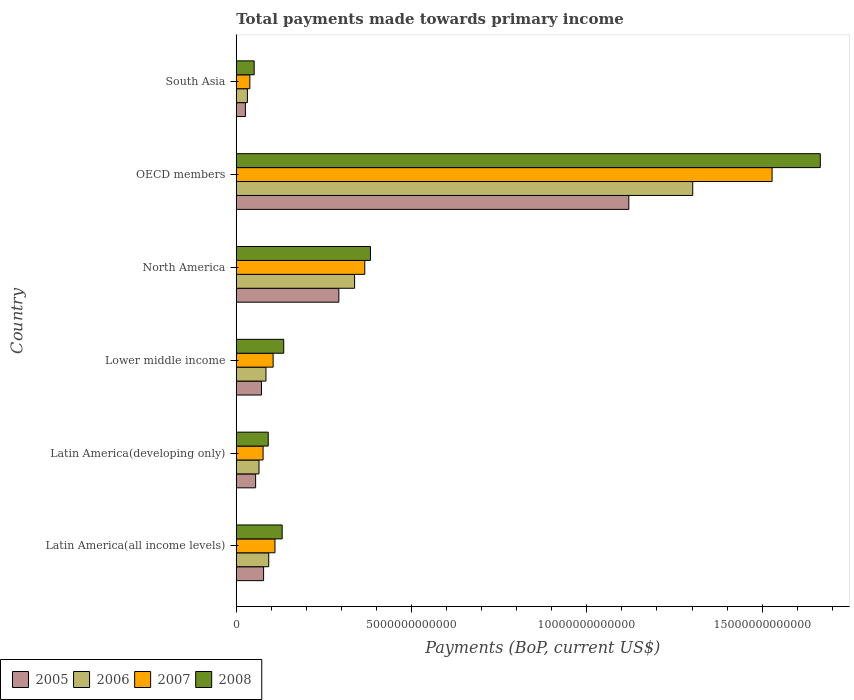How many groups of bars are there?
Provide a short and direct response. 6. Are the number of bars per tick equal to the number of legend labels?
Provide a succinct answer. Yes. Are the number of bars on each tick of the Y-axis equal?
Provide a succinct answer. Yes. What is the label of the 4th group of bars from the top?
Provide a succinct answer. Lower middle income. What is the total payments made towards primary income in 2008 in Latin America(all income levels)?
Your answer should be compact. 1.31e+12. Across all countries, what is the maximum total payments made towards primary income in 2006?
Your response must be concise. 1.30e+13. Across all countries, what is the minimum total payments made towards primary income in 2005?
Give a very brief answer. 2.61e+11. In which country was the total payments made towards primary income in 2007 maximum?
Make the answer very short. OECD members. In which country was the total payments made towards primary income in 2007 minimum?
Keep it short and to the point. South Asia. What is the total total payments made towards primary income in 2005 in the graph?
Provide a short and direct response. 1.64e+13. What is the difference between the total payments made towards primary income in 2005 in Latin America(all income levels) and that in North America?
Offer a terse response. -2.15e+12. What is the difference between the total payments made towards primary income in 2007 in Latin America(all income levels) and the total payments made towards primary income in 2008 in Lower middle income?
Keep it short and to the point. -2.50e+11. What is the average total payments made towards primary income in 2005 per country?
Keep it short and to the point. 2.74e+12. What is the difference between the total payments made towards primary income in 2008 and total payments made towards primary income in 2005 in Latin America(developing only)?
Ensure brevity in your answer.  3.60e+11. What is the ratio of the total payments made towards primary income in 2007 in Latin America(developing only) to that in OECD members?
Provide a succinct answer. 0.05. Is the difference between the total payments made towards primary income in 2008 in Lower middle income and South Asia greater than the difference between the total payments made towards primary income in 2005 in Lower middle income and South Asia?
Make the answer very short. Yes. What is the difference between the highest and the second highest total payments made towards primary income in 2008?
Your answer should be compact. 1.28e+13. What is the difference between the highest and the lowest total payments made towards primary income in 2005?
Make the answer very short. 1.09e+13. Is it the case that in every country, the sum of the total payments made towards primary income in 2006 and total payments made towards primary income in 2008 is greater than the sum of total payments made towards primary income in 2007 and total payments made towards primary income in 2005?
Your response must be concise. No. What does the 2nd bar from the bottom in Lower middle income represents?
Your answer should be very brief. 2006. Is it the case that in every country, the sum of the total payments made towards primary income in 2008 and total payments made towards primary income in 2007 is greater than the total payments made towards primary income in 2005?
Your response must be concise. Yes. How many bars are there?
Your answer should be very brief. 24. Are all the bars in the graph horizontal?
Ensure brevity in your answer.  Yes. What is the difference between two consecutive major ticks on the X-axis?
Your answer should be compact. 5.00e+12. Are the values on the major ticks of X-axis written in scientific E-notation?
Offer a terse response. No. Does the graph contain any zero values?
Give a very brief answer. No. How many legend labels are there?
Give a very brief answer. 4. How are the legend labels stacked?
Your answer should be very brief. Horizontal. What is the title of the graph?
Your response must be concise. Total payments made towards primary income. Does "1995" appear as one of the legend labels in the graph?
Make the answer very short. No. What is the label or title of the X-axis?
Ensure brevity in your answer.  Payments (BoP, current US$). What is the Payments (BoP, current US$) of 2005 in Latin America(all income levels)?
Provide a succinct answer. 7.80e+11. What is the Payments (BoP, current US$) of 2006 in Latin America(all income levels)?
Your answer should be very brief. 9.27e+11. What is the Payments (BoP, current US$) of 2007 in Latin America(all income levels)?
Provide a succinct answer. 1.10e+12. What is the Payments (BoP, current US$) of 2008 in Latin America(all income levels)?
Keep it short and to the point. 1.31e+12. What is the Payments (BoP, current US$) in 2005 in Latin America(developing only)?
Keep it short and to the point. 5.52e+11. What is the Payments (BoP, current US$) of 2006 in Latin America(developing only)?
Your answer should be compact. 6.49e+11. What is the Payments (BoP, current US$) in 2007 in Latin America(developing only)?
Your response must be concise. 7.65e+11. What is the Payments (BoP, current US$) of 2008 in Latin America(developing only)?
Give a very brief answer. 9.12e+11. What is the Payments (BoP, current US$) of 2005 in Lower middle income?
Your answer should be compact. 7.19e+11. What is the Payments (BoP, current US$) in 2006 in Lower middle income?
Your response must be concise. 8.48e+11. What is the Payments (BoP, current US$) of 2007 in Lower middle income?
Give a very brief answer. 1.05e+12. What is the Payments (BoP, current US$) in 2008 in Lower middle income?
Your response must be concise. 1.35e+12. What is the Payments (BoP, current US$) of 2005 in North America?
Offer a very short reply. 2.93e+12. What is the Payments (BoP, current US$) of 2006 in North America?
Give a very brief answer. 3.38e+12. What is the Payments (BoP, current US$) in 2007 in North America?
Your answer should be very brief. 3.67e+12. What is the Payments (BoP, current US$) of 2008 in North America?
Give a very brief answer. 3.83e+12. What is the Payments (BoP, current US$) of 2005 in OECD members?
Keep it short and to the point. 1.12e+13. What is the Payments (BoP, current US$) in 2006 in OECD members?
Your answer should be compact. 1.30e+13. What is the Payments (BoP, current US$) of 2007 in OECD members?
Provide a short and direct response. 1.53e+13. What is the Payments (BoP, current US$) of 2008 in OECD members?
Make the answer very short. 1.67e+13. What is the Payments (BoP, current US$) of 2005 in South Asia?
Provide a succinct answer. 2.61e+11. What is the Payments (BoP, current US$) in 2006 in South Asia?
Give a very brief answer. 3.18e+11. What is the Payments (BoP, current US$) in 2007 in South Asia?
Your answer should be very brief. 3.88e+11. What is the Payments (BoP, current US$) in 2008 in South Asia?
Offer a very short reply. 5.11e+11. Across all countries, what is the maximum Payments (BoP, current US$) of 2005?
Your answer should be very brief. 1.12e+13. Across all countries, what is the maximum Payments (BoP, current US$) of 2006?
Offer a terse response. 1.30e+13. Across all countries, what is the maximum Payments (BoP, current US$) of 2007?
Ensure brevity in your answer.  1.53e+13. Across all countries, what is the maximum Payments (BoP, current US$) in 2008?
Make the answer very short. 1.67e+13. Across all countries, what is the minimum Payments (BoP, current US$) of 2005?
Your response must be concise. 2.61e+11. Across all countries, what is the minimum Payments (BoP, current US$) of 2006?
Your response must be concise. 3.18e+11. Across all countries, what is the minimum Payments (BoP, current US$) of 2007?
Your response must be concise. 3.88e+11. Across all countries, what is the minimum Payments (BoP, current US$) in 2008?
Offer a very short reply. 5.11e+11. What is the total Payments (BoP, current US$) of 2005 in the graph?
Your answer should be compact. 1.64e+13. What is the total Payments (BoP, current US$) of 2006 in the graph?
Provide a succinct answer. 1.91e+13. What is the total Payments (BoP, current US$) in 2007 in the graph?
Keep it short and to the point. 2.23e+13. What is the total Payments (BoP, current US$) of 2008 in the graph?
Provide a short and direct response. 2.46e+13. What is the difference between the Payments (BoP, current US$) in 2005 in Latin America(all income levels) and that in Latin America(developing only)?
Offer a very short reply. 2.27e+11. What is the difference between the Payments (BoP, current US$) in 2006 in Latin America(all income levels) and that in Latin America(developing only)?
Your answer should be compact. 2.78e+11. What is the difference between the Payments (BoP, current US$) in 2007 in Latin America(all income levels) and that in Latin America(developing only)?
Your answer should be very brief. 3.39e+11. What is the difference between the Payments (BoP, current US$) of 2008 in Latin America(all income levels) and that in Latin America(developing only)?
Offer a very short reply. 3.97e+11. What is the difference between the Payments (BoP, current US$) of 2005 in Latin America(all income levels) and that in Lower middle income?
Provide a short and direct response. 6.05e+1. What is the difference between the Payments (BoP, current US$) of 2006 in Latin America(all income levels) and that in Lower middle income?
Provide a short and direct response. 7.89e+1. What is the difference between the Payments (BoP, current US$) of 2007 in Latin America(all income levels) and that in Lower middle income?
Ensure brevity in your answer.  5.23e+1. What is the difference between the Payments (BoP, current US$) of 2008 in Latin America(all income levels) and that in Lower middle income?
Your response must be concise. -4.54e+1. What is the difference between the Payments (BoP, current US$) in 2005 in Latin America(all income levels) and that in North America?
Give a very brief answer. -2.15e+12. What is the difference between the Payments (BoP, current US$) in 2006 in Latin America(all income levels) and that in North America?
Make the answer very short. -2.45e+12. What is the difference between the Payments (BoP, current US$) of 2007 in Latin America(all income levels) and that in North America?
Provide a short and direct response. -2.56e+12. What is the difference between the Payments (BoP, current US$) in 2008 in Latin America(all income levels) and that in North America?
Provide a succinct answer. -2.52e+12. What is the difference between the Payments (BoP, current US$) of 2005 in Latin America(all income levels) and that in OECD members?
Provide a short and direct response. -1.04e+13. What is the difference between the Payments (BoP, current US$) in 2006 in Latin America(all income levels) and that in OECD members?
Offer a very short reply. -1.21e+13. What is the difference between the Payments (BoP, current US$) of 2007 in Latin America(all income levels) and that in OECD members?
Offer a terse response. -1.42e+13. What is the difference between the Payments (BoP, current US$) of 2008 in Latin America(all income levels) and that in OECD members?
Offer a terse response. -1.54e+13. What is the difference between the Payments (BoP, current US$) in 2005 in Latin America(all income levels) and that in South Asia?
Your answer should be very brief. 5.19e+11. What is the difference between the Payments (BoP, current US$) in 2006 in Latin America(all income levels) and that in South Asia?
Offer a very short reply. 6.09e+11. What is the difference between the Payments (BoP, current US$) of 2007 in Latin America(all income levels) and that in South Asia?
Ensure brevity in your answer.  7.17e+11. What is the difference between the Payments (BoP, current US$) of 2008 in Latin America(all income levels) and that in South Asia?
Your answer should be very brief. 7.98e+11. What is the difference between the Payments (BoP, current US$) in 2005 in Latin America(developing only) and that in Lower middle income?
Offer a terse response. -1.67e+11. What is the difference between the Payments (BoP, current US$) of 2006 in Latin America(developing only) and that in Lower middle income?
Keep it short and to the point. -1.99e+11. What is the difference between the Payments (BoP, current US$) of 2007 in Latin America(developing only) and that in Lower middle income?
Your answer should be compact. -2.86e+11. What is the difference between the Payments (BoP, current US$) of 2008 in Latin America(developing only) and that in Lower middle income?
Your response must be concise. -4.42e+11. What is the difference between the Payments (BoP, current US$) of 2005 in Latin America(developing only) and that in North America?
Give a very brief answer. -2.37e+12. What is the difference between the Payments (BoP, current US$) in 2006 in Latin America(developing only) and that in North America?
Provide a succinct answer. -2.73e+12. What is the difference between the Payments (BoP, current US$) in 2007 in Latin America(developing only) and that in North America?
Give a very brief answer. -2.90e+12. What is the difference between the Payments (BoP, current US$) of 2008 in Latin America(developing only) and that in North America?
Keep it short and to the point. -2.92e+12. What is the difference between the Payments (BoP, current US$) of 2005 in Latin America(developing only) and that in OECD members?
Give a very brief answer. -1.06e+13. What is the difference between the Payments (BoP, current US$) of 2006 in Latin America(developing only) and that in OECD members?
Ensure brevity in your answer.  -1.24e+13. What is the difference between the Payments (BoP, current US$) of 2007 in Latin America(developing only) and that in OECD members?
Your response must be concise. -1.45e+13. What is the difference between the Payments (BoP, current US$) of 2008 in Latin America(developing only) and that in OECD members?
Your answer should be very brief. -1.57e+13. What is the difference between the Payments (BoP, current US$) in 2005 in Latin America(developing only) and that in South Asia?
Provide a short and direct response. 2.92e+11. What is the difference between the Payments (BoP, current US$) of 2006 in Latin America(developing only) and that in South Asia?
Provide a short and direct response. 3.31e+11. What is the difference between the Payments (BoP, current US$) of 2007 in Latin America(developing only) and that in South Asia?
Provide a succinct answer. 3.78e+11. What is the difference between the Payments (BoP, current US$) of 2008 in Latin America(developing only) and that in South Asia?
Your response must be concise. 4.01e+11. What is the difference between the Payments (BoP, current US$) of 2005 in Lower middle income and that in North America?
Your answer should be compact. -2.21e+12. What is the difference between the Payments (BoP, current US$) of 2006 in Lower middle income and that in North America?
Ensure brevity in your answer.  -2.53e+12. What is the difference between the Payments (BoP, current US$) of 2007 in Lower middle income and that in North America?
Your answer should be compact. -2.61e+12. What is the difference between the Payments (BoP, current US$) in 2008 in Lower middle income and that in North America?
Your answer should be very brief. -2.47e+12. What is the difference between the Payments (BoP, current US$) in 2005 in Lower middle income and that in OECD members?
Offer a very short reply. -1.05e+13. What is the difference between the Payments (BoP, current US$) in 2006 in Lower middle income and that in OECD members?
Offer a very short reply. -1.22e+13. What is the difference between the Payments (BoP, current US$) in 2007 in Lower middle income and that in OECD members?
Provide a short and direct response. -1.42e+13. What is the difference between the Payments (BoP, current US$) in 2008 in Lower middle income and that in OECD members?
Offer a terse response. -1.53e+13. What is the difference between the Payments (BoP, current US$) of 2005 in Lower middle income and that in South Asia?
Provide a short and direct response. 4.59e+11. What is the difference between the Payments (BoP, current US$) of 2006 in Lower middle income and that in South Asia?
Your response must be concise. 5.30e+11. What is the difference between the Payments (BoP, current US$) of 2007 in Lower middle income and that in South Asia?
Offer a terse response. 6.64e+11. What is the difference between the Payments (BoP, current US$) in 2008 in Lower middle income and that in South Asia?
Provide a succinct answer. 8.43e+11. What is the difference between the Payments (BoP, current US$) in 2005 in North America and that in OECD members?
Offer a terse response. -8.27e+12. What is the difference between the Payments (BoP, current US$) of 2006 in North America and that in OECD members?
Offer a terse response. -9.65e+12. What is the difference between the Payments (BoP, current US$) of 2007 in North America and that in OECD members?
Your answer should be very brief. -1.16e+13. What is the difference between the Payments (BoP, current US$) of 2008 in North America and that in OECD members?
Give a very brief answer. -1.28e+13. What is the difference between the Payments (BoP, current US$) of 2005 in North America and that in South Asia?
Keep it short and to the point. 2.67e+12. What is the difference between the Payments (BoP, current US$) in 2006 in North America and that in South Asia?
Provide a short and direct response. 3.06e+12. What is the difference between the Payments (BoP, current US$) of 2007 in North America and that in South Asia?
Your response must be concise. 3.28e+12. What is the difference between the Payments (BoP, current US$) of 2008 in North America and that in South Asia?
Give a very brief answer. 3.32e+12. What is the difference between the Payments (BoP, current US$) of 2005 in OECD members and that in South Asia?
Your response must be concise. 1.09e+13. What is the difference between the Payments (BoP, current US$) in 2006 in OECD members and that in South Asia?
Provide a succinct answer. 1.27e+13. What is the difference between the Payments (BoP, current US$) in 2007 in OECD members and that in South Asia?
Make the answer very short. 1.49e+13. What is the difference between the Payments (BoP, current US$) of 2008 in OECD members and that in South Asia?
Ensure brevity in your answer.  1.61e+13. What is the difference between the Payments (BoP, current US$) of 2005 in Latin America(all income levels) and the Payments (BoP, current US$) of 2006 in Latin America(developing only)?
Your answer should be very brief. 1.31e+11. What is the difference between the Payments (BoP, current US$) in 2005 in Latin America(all income levels) and the Payments (BoP, current US$) in 2007 in Latin America(developing only)?
Provide a short and direct response. 1.43e+1. What is the difference between the Payments (BoP, current US$) in 2005 in Latin America(all income levels) and the Payments (BoP, current US$) in 2008 in Latin America(developing only)?
Offer a terse response. -1.33e+11. What is the difference between the Payments (BoP, current US$) of 2006 in Latin America(all income levels) and the Payments (BoP, current US$) of 2007 in Latin America(developing only)?
Provide a short and direct response. 1.61e+11. What is the difference between the Payments (BoP, current US$) of 2006 in Latin America(all income levels) and the Payments (BoP, current US$) of 2008 in Latin America(developing only)?
Provide a short and direct response. 1.44e+1. What is the difference between the Payments (BoP, current US$) in 2007 in Latin America(all income levels) and the Payments (BoP, current US$) in 2008 in Latin America(developing only)?
Offer a very short reply. 1.92e+11. What is the difference between the Payments (BoP, current US$) of 2005 in Latin America(all income levels) and the Payments (BoP, current US$) of 2006 in Lower middle income?
Offer a very short reply. -6.81e+1. What is the difference between the Payments (BoP, current US$) in 2005 in Latin America(all income levels) and the Payments (BoP, current US$) in 2007 in Lower middle income?
Ensure brevity in your answer.  -2.72e+11. What is the difference between the Payments (BoP, current US$) of 2005 in Latin America(all income levels) and the Payments (BoP, current US$) of 2008 in Lower middle income?
Make the answer very short. -5.75e+11. What is the difference between the Payments (BoP, current US$) in 2006 in Latin America(all income levels) and the Payments (BoP, current US$) in 2007 in Lower middle income?
Give a very brief answer. -1.25e+11. What is the difference between the Payments (BoP, current US$) in 2006 in Latin America(all income levels) and the Payments (BoP, current US$) in 2008 in Lower middle income?
Offer a very short reply. -4.28e+11. What is the difference between the Payments (BoP, current US$) in 2007 in Latin America(all income levels) and the Payments (BoP, current US$) in 2008 in Lower middle income?
Your response must be concise. -2.50e+11. What is the difference between the Payments (BoP, current US$) in 2005 in Latin America(all income levels) and the Payments (BoP, current US$) in 2006 in North America?
Provide a short and direct response. -2.60e+12. What is the difference between the Payments (BoP, current US$) in 2005 in Latin America(all income levels) and the Payments (BoP, current US$) in 2007 in North America?
Offer a terse response. -2.89e+12. What is the difference between the Payments (BoP, current US$) of 2005 in Latin America(all income levels) and the Payments (BoP, current US$) of 2008 in North America?
Your response must be concise. -3.05e+12. What is the difference between the Payments (BoP, current US$) in 2006 in Latin America(all income levels) and the Payments (BoP, current US$) in 2007 in North America?
Give a very brief answer. -2.74e+12. What is the difference between the Payments (BoP, current US$) of 2006 in Latin America(all income levels) and the Payments (BoP, current US$) of 2008 in North America?
Keep it short and to the point. -2.90e+12. What is the difference between the Payments (BoP, current US$) in 2007 in Latin America(all income levels) and the Payments (BoP, current US$) in 2008 in North America?
Keep it short and to the point. -2.72e+12. What is the difference between the Payments (BoP, current US$) of 2005 in Latin America(all income levels) and the Payments (BoP, current US$) of 2006 in OECD members?
Offer a terse response. -1.22e+13. What is the difference between the Payments (BoP, current US$) of 2005 in Latin America(all income levels) and the Payments (BoP, current US$) of 2007 in OECD members?
Make the answer very short. -1.45e+13. What is the difference between the Payments (BoP, current US$) of 2005 in Latin America(all income levels) and the Payments (BoP, current US$) of 2008 in OECD members?
Give a very brief answer. -1.59e+13. What is the difference between the Payments (BoP, current US$) in 2006 in Latin America(all income levels) and the Payments (BoP, current US$) in 2007 in OECD members?
Your response must be concise. -1.44e+13. What is the difference between the Payments (BoP, current US$) in 2006 in Latin America(all income levels) and the Payments (BoP, current US$) in 2008 in OECD members?
Provide a short and direct response. -1.57e+13. What is the difference between the Payments (BoP, current US$) of 2007 in Latin America(all income levels) and the Payments (BoP, current US$) of 2008 in OECD members?
Your answer should be very brief. -1.56e+13. What is the difference between the Payments (BoP, current US$) in 2005 in Latin America(all income levels) and the Payments (BoP, current US$) in 2006 in South Asia?
Ensure brevity in your answer.  4.62e+11. What is the difference between the Payments (BoP, current US$) in 2005 in Latin America(all income levels) and the Payments (BoP, current US$) in 2007 in South Asia?
Make the answer very short. 3.92e+11. What is the difference between the Payments (BoP, current US$) in 2005 in Latin America(all income levels) and the Payments (BoP, current US$) in 2008 in South Asia?
Your answer should be compact. 2.68e+11. What is the difference between the Payments (BoP, current US$) in 2006 in Latin America(all income levels) and the Payments (BoP, current US$) in 2007 in South Asia?
Make the answer very short. 5.39e+11. What is the difference between the Payments (BoP, current US$) of 2006 in Latin America(all income levels) and the Payments (BoP, current US$) of 2008 in South Asia?
Offer a terse response. 4.15e+11. What is the difference between the Payments (BoP, current US$) of 2007 in Latin America(all income levels) and the Payments (BoP, current US$) of 2008 in South Asia?
Ensure brevity in your answer.  5.93e+11. What is the difference between the Payments (BoP, current US$) in 2005 in Latin America(developing only) and the Payments (BoP, current US$) in 2006 in Lower middle income?
Your response must be concise. -2.95e+11. What is the difference between the Payments (BoP, current US$) in 2005 in Latin America(developing only) and the Payments (BoP, current US$) in 2007 in Lower middle income?
Make the answer very short. -4.99e+11. What is the difference between the Payments (BoP, current US$) of 2005 in Latin America(developing only) and the Payments (BoP, current US$) of 2008 in Lower middle income?
Your answer should be very brief. -8.02e+11. What is the difference between the Payments (BoP, current US$) in 2006 in Latin America(developing only) and the Payments (BoP, current US$) in 2007 in Lower middle income?
Your response must be concise. -4.03e+11. What is the difference between the Payments (BoP, current US$) in 2006 in Latin America(developing only) and the Payments (BoP, current US$) in 2008 in Lower middle income?
Keep it short and to the point. -7.05e+11. What is the difference between the Payments (BoP, current US$) in 2007 in Latin America(developing only) and the Payments (BoP, current US$) in 2008 in Lower middle income?
Offer a terse response. -5.89e+11. What is the difference between the Payments (BoP, current US$) in 2005 in Latin America(developing only) and the Payments (BoP, current US$) in 2006 in North America?
Ensure brevity in your answer.  -2.82e+12. What is the difference between the Payments (BoP, current US$) of 2005 in Latin America(developing only) and the Payments (BoP, current US$) of 2007 in North America?
Your response must be concise. -3.11e+12. What is the difference between the Payments (BoP, current US$) in 2005 in Latin America(developing only) and the Payments (BoP, current US$) in 2008 in North America?
Make the answer very short. -3.28e+12. What is the difference between the Payments (BoP, current US$) in 2006 in Latin America(developing only) and the Payments (BoP, current US$) in 2007 in North America?
Your answer should be compact. -3.02e+12. What is the difference between the Payments (BoP, current US$) in 2006 in Latin America(developing only) and the Payments (BoP, current US$) in 2008 in North America?
Give a very brief answer. -3.18e+12. What is the difference between the Payments (BoP, current US$) in 2007 in Latin America(developing only) and the Payments (BoP, current US$) in 2008 in North America?
Provide a short and direct response. -3.06e+12. What is the difference between the Payments (BoP, current US$) in 2005 in Latin America(developing only) and the Payments (BoP, current US$) in 2006 in OECD members?
Ensure brevity in your answer.  -1.25e+13. What is the difference between the Payments (BoP, current US$) of 2005 in Latin America(developing only) and the Payments (BoP, current US$) of 2007 in OECD members?
Provide a short and direct response. -1.47e+13. What is the difference between the Payments (BoP, current US$) in 2005 in Latin America(developing only) and the Payments (BoP, current US$) in 2008 in OECD members?
Your response must be concise. -1.61e+13. What is the difference between the Payments (BoP, current US$) of 2006 in Latin America(developing only) and the Payments (BoP, current US$) of 2007 in OECD members?
Provide a short and direct response. -1.46e+13. What is the difference between the Payments (BoP, current US$) of 2006 in Latin America(developing only) and the Payments (BoP, current US$) of 2008 in OECD members?
Your answer should be compact. -1.60e+13. What is the difference between the Payments (BoP, current US$) in 2007 in Latin America(developing only) and the Payments (BoP, current US$) in 2008 in OECD members?
Offer a very short reply. -1.59e+13. What is the difference between the Payments (BoP, current US$) of 2005 in Latin America(developing only) and the Payments (BoP, current US$) of 2006 in South Asia?
Your response must be concise. 2.34e+11. What is the difference between the Payments (BoP, current US$) of 2005 in Latin America(developing only) and the Payments (BoP, current US$) of 2007 in South Asia?
Your response must be concise. 1.65e+11. What is the difference between the Payments (BoP, current US$) of 2005 in Latin America(developing only) and the Payments (BoP, current US$) of 2008 in South Asia?
Your answer should be very brief. 4.13e+1. What is the difference between the Payments (BoP, current US$) of 2006 in Latin America(developing only) and the Payments (BoP, current US$) of 2007 in South Asia?
Give a very brief answer. 2.61e+11. What is the difference between the Payments (BoP, current US$) of 2006 in Latin America(developing only) and the Payments (BoP, current US$) of 2008 in South Asia?
Offer a terse response. 1.38e+11. What is the difference between the Payments (BoP, current US$) in 2007 in Latin America(developing only) and the Payments (BoP, current US$) in 2008 in South Asia?
Offer a very short reply. 2.54e+11. What is the difference between the Payments (BoP, current US$) in 2005 in Lower middle income and the Payments (BoP, current US$) in 2006 in North America?
Your response must be concise. -2.66e+12. What is the difference between the Payments (BoP, current US$) in 2005 in Lower middle income and the Payments (BoP, current US$) in 2007 in North America?
Offer a very short reply. -2.95e+12. What is the difference between the Payments (BoP, current US$) of 2005 in Lower middle income and the Payments (BoP, current US$) of 2008 in North America?
Keep it short and to the point. -3.11e+12. What is the difference between the Payments (BoP, current US$) in 2006 in Lower middle income and the Payments (BoP, current US$) in 2007 in North America?
Your answer should be very brief. -2.82e+12. What is the difference between the Payments (BoP, current US$) of 2006 in Lower middle income and the Payments (BoP, current US$) of 2008 in North America?
Your answer should be compact. -2.98e+12. What is the difference between the Payments (BoP, current US$) of 2007 in Lower middle income and the Payments (BoP, current US$) of 2008 in North America?
Ensure brevity in your answer.  -2.78e+12. What is the difference between the Payments (BoP, current US$) of 2005 in Lower middle income and the Payments (BoP, current US$) of 2006 in OECD members?
Ensure brevity in your answer.  -1.23e+13. What is the difference between the Payments (BoP, current US$) of 2005 in Lower middle income and the Payments (BoP, current US$) of 2007 in OECD members?
Provide a succinct answer. -1.46e+13. What is the difference between the Payments (BoP, current US$) in 2005 in Lower middle income and the Payments (BoP, current US$) in 2008 in OECD members?
Give a very brief answer. -1.59e+13. What is the difference between the Payments (BoP, current US$) in 2006 in Lower middle income and the Payments (BoP, current US$) in 2007 in OECD members?
Keep it short and to the point. -1.44e+13. What is the difference between the Payments (BoP, current US$) in 2006 in Lower middle income and the Payments (BoP, current US$) in 2008 in OECD members?
Your answer should be compact. -1.58e+13. What is the difference between the Payments (BoP, current US$) of 2007 in Lower middle income and the Payments (BoP, current US$) of 2008 in OECD members?
Provide a short and direct response. -1.56e+13. What is the difference between the Payments (BoP, current US$) of 2005 in Lower middle income and the Payments (BoP, current US$) of 2006 in South Asia?
Your answer should be very brief. 4.01e+11. What is the difference between the Payments (BoP, current US$) in 2005 in Lower middle income and the Payments (BoP, current US$) in 2007 in South Asia?
Offer a terse response. 3.32e+11. What is the difference between the Payments (BoP, current US$) of 2005 in Lower middle income and the Payments (BoP, current US$) of 2008 in South Asia?
Ensure brevity in your answer.  2.08e+11. What is the difference between the Payments (BoP, current US$) in 2006 in Lower middle income and the Payments (BoP, current US$) in 2007 in South Asia?
Your answer should be very brief. 4.60e+11. What is the difference between the Payments (BoP, current US$) of 2006 in Lower middle income and the Payments (BoP, current US$) of 2008 in South Asia?
Keep it short and to the point. 3.37e+11. What is the difference between the Payments (BoP, current US$) in 2007 in Lower middle income and the Payments (BoP, current US$) in 2008 in South Asia?
Keep it short and to the point. 5.41e+11. What is the difference between the Payments (BoP, current US$) in 2005 in North America and the Payments (BoP, current US$) in 2006 in OECD members?
Make the answer very short. -1.01e+13. What is the difference between the Payments (BoP, current US$) of 2005 in North America and the Payments (BoP, current US$) of 2007 in OECD members?
Make the answer very short. -1.24e+13. What is the difference between the Payments (BoP, current US$) in 2005 in North America and the Payments (BoP, current US$) in 2008 in OECD members?
Your answer should be compact. -1.37e+13. What is the difference between the Payments (BoP, current US$) of 2006 in North America and the Payments (BoP, current US$) of 2007 in OECD members?
Make the answer very short. -1.19e+13. What is the difference between the Payments (BoP, current US$) in 2006 in North America and the Payments (BoP, current US$) in 2008 in OECD members?
Provide a succinct answer. -1.33e+13. What is the difference between the Payments (BoP, current US$) of 2007 in North America and the Payments (BoP, current US$) of 2008 in OECD members?
Give a very brief answer. -1.30e+13. What is the difference between the Payments (BoP, current US$) of 2005 in North America and the Payments (BoP, current US$) of 2006 in South Asia?
Give a very brief answer. 2.61e+12. What is the difference between the Payments (BoP, current US$) in 2005 in North America and the Payments (BoP, current US$) in 2007 in South Asia?
Provide a short and direct response. 2.54e+12. What is the difference between the Payments (BoP, current US$) of 2005 in North America and the Payments (BoP, current US$) of 2008 in South Asia?
Provide a succinct answer. 2.41e+12. What is the difference between the Payments (BoP, current US$) in 2006 in North America and the Payments (BoP, current US$) in 2007 in South Asia?
Keep it short and to the point. 2.99e+12. What is the difference between the Payments (BoP, current US$) in 2006 in North America and the Payments (BoP, current US$) in 2008 in South Asia?
Give a very brief answer. 2.86e+12. What is the difference between the Payments (BoP, current US$) of 2007 in North America and the Payments (BoP, current US$) of 2008 in South Asia?
Provide a succinct answer. 3.15e+12. What is the difference between the Payments (BoP, current US$) of 2005 in OECD members and the Payments (BoP, current US$) of 2006 in South Asia?
Provide a short and direct response. 1.09e+13. What is the difference between the Payments (BoP, current US$) of 2005 in OECD members and the Payments (BoP, current US$) of 2007 in South Asia?
Offer a terse response. 1.08e+13. What is the difference between the Payments (BoP, current US$) in 2005 in OECD members and the Payments (BoP, current US$) in 2008 in South Asia?
Your response must be concise. 1.07e+13. What is the difference between the Payments (BoP, current US$) in 2006 in OECD members and the Payments (BoP, current US$) in 2007 in South Asia?
Your response must be concise. 1.26e+13. What is the difference between the Payments (BoP, current US$) of 2006 in OECD members and the Payments (BoP, current US$) of 2008 in South Asia?
Ensure brevity in your answer.  1.25e+13. What is the difference between the Payments (BoP, current US$) in 2007 in OECD members and the Payments (BoP, current US$) in 2008 in South Asia?
Your response must be concise. 1.48e+13. What is the average Payments (BoP, current US$) in 2005 per country?
Provide a succinct answer. 2.74e+12. What is the average Payments (BoP, current US$) of 2006 per country?
Give a very brief answer. 3.19e+12. What is the average Payments (BoP, current US$) in 2007 per country?
Your answer should be very brief. 3.71e+12. What is the average Payments (BoP, current US$) in 2008 per country?
Your answer should be compact. 4.10e+12. What is the difference between the Payments (BoP, current US$) in 2005 and Payments (BoP, current US$) in 2006 in Latin America(all income levels)?
Your answer should be very brief. -1.47e+11. What is the difference between the Payments (BoP, current US$) of 2005 and Payments (BoP, current US$) of 2007 in Latin America(all income levels)?
Provide a short and direct response. -3.25e+11. What is the difference between the Payments (BoP, current US$) in 2005 and Payments (BoP, current US$) in 2008 in Latin America(all income levels)?
Your answer should be compact. -5.29e+11. What is the difference between the Payments (BoP, current US$) in 2006 and Payments (BoP, current US$) in 2007 in Latin America(all income levels)?
Offer a terse response. -1.78e+11. What is the difference between the Payments (BoP, current US$) of 2006 and Payments (BoP, current US$) of 2008 in Latin America(all income levels)?
Your answer should be very brief. -3.82e+11. What is the difference between the Payments (BoP, current US$) of 2007 and Payments (BoP, current US$) of 2008 in Latin America(all income levels)?
Provide a short and direct response. -2.05e+11. What is the difference between the Payments (BoP, current US$) of 2005 and Payments (BoP, current US$) of 2006 in Latin America(developing only)?
Offer a very short reply. -9.65e+1. What is the difference between the Payments (BoP, current US$) in 2005 and Payments (BoP, current US$) in 2007 in Latin America(developing only)?
Ensure brevity in your answer.  -2.13e+11. What is the difference between the Payments (BoP, current US$) of 2005 and Payments (BoP, current US$) of 2008 in Latin America(developing only)?
Your response must be concise. -3.60e+11. What is the difference between the Payments (BoP, current US$) in 2006 and Payments (BoP, current US$) in 2007 in Latin America(developing only)?
Provide a short and direct response. -1.16e+11. What is the difference between the Payments (BoP, current US$) of 2006 and Payments (BoP, current US$) of 2008 in Latin America(developing only)?
Offer a terse response. -2.63e+11. What is the difference between the Payments (BoP, current US$) in 2007 and Payments (BoP, current US$) in 2008 in Latin America(developing only)?
Offer a terse response. -1.47e+11. What is the difference between the Payments (BoP, current US$) in 2005 and Payments (BoP, current US$) in 2006 in Lower middle income?
Provide a succinct answer. -1.29e+11. What is the difference between the Payments (BoP, current US$) of 2005 and Payments (BoP, current US$) of 2007 in Lower middle income?
Give a very brief answer. -3.33e+11. What is the difference between the Payments (BoP, current US$) in 2005 and Payments (BoP, current US$) in 2008 in Lower middle income?
Make the answer very short. -6.35e+11. What is the difference between the Payments (BoP, current US$) of 2006 and Payments (BoP, current US$) of 2007 in Lower middle income?
Your response must be concise. -2.04e+11. What is the difference between the Payments (BoP, current US$) in 2006 and Payments (BoP, current US$) in 2008 in Lower middle income?
Provide a short and direct response. -5.07e+11. What is the difference between the Payments (BoP, current US$) in 2007 and Payments (BoP, current US$) in 2008 in Lower middle income?
Your response must be concise. -3.03e+11. What is the difference between the Payments (BoP, current US$) in 2005 and Payments (BoP, current US$) in 2006 in North America?
Make the answer very short. -4.49e+11. What is the difference between the Payments (BoP, current US$) in 2005 and Payments (BoP, current US$) in 2007 in North America?
Give a very brief answer. -7.40e+11. What is the difference between the Payments (BoP, current US$) of 2005 and Payments (BoP, current US$) of 2008 in North America?
Make the answer very short. -9.02e+11. What is the difference between the Payments (BoP, current US$) in 2006 and Payments (BoP, current US$) in 2007 in North America?
Provide a succinct answer. -2.91e+11. What is the difference between the Payments (BoP, current US$) in 2006 and Payments (BoP, current US$) in 2008 in North America?
Make the answer very short. -4.53e+11. What is the difference between the Payments (BoP, current US$) of 2007 and Payments (BoP, current US$) of 2008 in North America?
Offer a terse response. -1.62e+11. What is the difference between the Payments (BoP, current US$) of 2005 and Payments (BoP, current US$) of 2006 in OECD members?
Make the answer very short. -1.82e+12. What is the difference between the Payments (BoP, current US$) of 2005 and Payments (BoP, current US$) of 2007 in OECD members?
Offer a very short reply. -4.09e+12. What is the difference between the Payments (BoP, current US$) of 2005 and Payments (BoP, current US$) of 2008 in OECD members?
Keep it short and to the point. -5.46e+12. What is the difference between the Payments (BoP, current US$) in 2006 and Payments (BoP, current US$) in 2007 in OECD members?
Keep it short and to the point. -2.26e+12. What is the difference between the Payments (BoP, current US$) in 2006 and Payments (BoP, current US$) in 2008 in OECD members?
Provide a short and direct response. -3.64e+12. What is the difference between the Payments (BoP, current US$) in 2007 and Payments (BoP, current US$) in 2008 in OECD members?
Provide a succinct answer. -1.38e+12. What is the difference between the Payments (BoP, current US$) of 2005 and Payments (BoP, current US$) of 2006 in South Asia?
Offer a very short reply. -5.75e+1. What is the difference between the Payments (BoP, current US$) of 2005 and Payments (BoP, current US$) of 2007 in South Asia?
Your response must be concise. -1.27e+11. What is the difference between the Payments (BoP, current US$) of 2005 and Payments (BoP, current US$) of 2008 in South Asia?
Give a very brief answer. -2.51e+11. What is the difference between the Payments (BoP, current US$) of 2006 and Payments (BoP, current US$) of 2007 in South Asia?
Offer a terse response. -6.95e+1. What is the difference between the Payments (BoP, current US$) in 2006 and Payments (BoP, current US$) in 2008 in South Asia?
Give a very brief answer. -1.93e+11. What is the difference between the Payments (BoP, current US$) of 2007 and Payments (BoP, current US$) of 2008 in South Asia?
Give a very brief answer. -1.24e+11. What is the ratio of the Payments (BoP, current US$) in 2005 in Latin America(all income levels) to that in Latin America(developing only)?
Offer a very short reply. 1.41. What is the ratio of the Payments (BoP, current US$) of 2006 in Latin America(all income levels) to that in Latin America(developing only)?
Provide a short and direct response. 1.43. What is the ratio of the Payments (BoP, current US$) in 2007 in Latin America(all income levels) to that in Latin America(developing only)?
Keep it short and to the point. 1.44. What is the ratio of the Payments (BoP, current US$) in 2008 in Latin America(all income levels) to that in Latin America(developing only)?
Your answer should be very brief. 1.44. What is the ratio of the Payments (BoP, current US$) in 2005 in Latin America(all income levels) to that in Lower middle income?
Offer a very short reply. 1.08. What is the ratio of the Payments (BoP, current US$) of 2006 in Latin America(all income levels) to that in Lower middle income?
Your response must be concise. 1.09. What is the ratio of the Payments (BoP, current US$) in 2007 in Latin America(all income levels) to that in Lower middle income?
Provide a short and direct response. 1.05. What is the ratio of the Payments (BoP, current US$) in 2008 in Latin America(all income levels) to that in Lower middle income?
Ensure brevity in your answer.  0.97. What is the ratio of the Payments (BoP, current US$) in 2005 in Latin America(all income levels) to that in North America?
Your answer should be very brief. 0.27. What is the ratio of the Payments (BoP, current US$) of 2006 in Latin America(all income levels) to that in North America?
Give a very brief answer. 0.27. What is the ratio of the Payments (BoP, current US$) in 2007 in Latin America(all income levels) to that in North America?
Your answer should be compact. 0.3. What is the ratio of the Payments (BoP, current US$) of 2008 in Latin America(all income levels) to that in North America?
Provide a short and direct response. 0.34. What is the ratio of the Payments (BoP, current US$) of 2005 in Latin America(all income levels) to that in OECD members?
Keep it short and to the point. 0.07. What is the ratio of the Payments (BoP, current US$) in 2006 in Latin America(all income levels) to that in OECD members?
Ensure brevity in your answer.  0.07. What is the ratio of the Payments (BoP, current US$) of 2007 in Latin America(all income levels) to that in OECD members?
Offer a very short reply. 0.07. What is the ratio of the Payments (BoP, current US$) in 2008 in Latin America(all income levels) to that in OECD members?
Ensure brevity in your answer.  0.08. What is the ratio of the Payments (BoP, current US$) of 2005 in Latin America(all income levels) to that in South Asia?
Make the answer very short. 2.99. What is the ratio of the Payments (BoP, current US$) in 2006 in Latin America(all income levels) to that in South Asia?
Your answer should be compact. 2.91. What is the ratio of the Payments (BoP, current US$) in 2007 in Latin America(all income levels) to that in South Asia?
Offer a very short reply. 2.85. What is the ratio of the Payments (BoP, current US$) of 2008 in Latin America(all income levels) to that in South Asia?
Offer a terse response. 2.56. What is the ratio of the Payments (BoP, current US$) in 2005 in Latin America(developing only) to that in Lower middle income?
Ensure brevity in your answer.  0.77. What is the ratio of the Payments (BoP, current US$) in 2006 in Latin America(developing only) to that in Lower middle income?
Make the answer very short. 0.77. What is the ratio of the Payments (BoP, current US$) in 2007 in Latin America(developing only) to that in Lower middle income?
Ensure brevity in your answer.  0.73. What is the ratio of the Payments (BoP, current US$) in 2008 in Latin America(developing only) to that in Lower middle income?
Offer a terse response. 0.67. What is the ratio of the Payments (BoP, current US$) in 2005 in Latin America(developing only) to that in North America?
Keep it short and to the point. 0.19. What is the ratio of the Payments (BoP, current US$) of 2006 in Latin America(developing only) to that in North America?
Offer a very short reply. 0.19. What is the ratio of the Payments (BoP, current US$) in 2007 in Latin America(developing only) to that in North America?
Make the answer very short. 0.21. What is the ratio of the Payments (BoP, current US$) in 2008 in Latin America(developing only) to that in North America?
Offer a very short reply. 0.24. What is the ratio of the Payments (BoP, current US$) of 2005 in Latin America(developing only) to that in OECD members?
Your answer should be compact. 0.05. What is the ratio of the Payments (BoP, current US$) in 2006 in Latin America(developing only) to that in OECD members?
Your response must be concise. 0.05. What is the ratio of the Payments (BoP, current US$) in 2007 in Latin America(developing only) to that in OECD members?
Provide a short and direct response. 0.05. What is the ratio of the Payments (BoP, current US$) in 2008 in Latin America(developing only) to that in OECD members?
Make the answer very short. 0.05. What is the ratio of the Payments (BoP, current US$) of 2005 in Latin America(developing only) to that in South Asia?
Give a very brief answer. 2.12. What is the ratio of the Payments (BoP, current US$) in 2006 in Latin America(developing only) to that in South Asia?
Give a very brief answer. 2.04. What is the ratio of the Payments (BoP, current US$) in 2007 in Latin America(developing only) to that in South Asia?
Your answer should be compact. 1.97. What is the ratio of the Payments (BoP, current US$) of 2008 in Latin America(developing only) to that in South Asia?
Offer a very short reply. 1.78. What is the ratio of the Payments (BoP, current US$) in 2005 in Lower middle income to that in North America?
Ensure brevity in your answer.  0.25. What is the ratio of the Payments (BoP, current US$) of 2006 in Lower middle income to that in North America?
Make the answer very short. 0.25. What is the ratio of the Payments (BoP, current US$) in 2007 in Lower middle income to that in North America?
Your answer should be very brief. 0.29. What is the ratio of the Payments (BoP, current US$) of 2008 in Lower middle income to that in North America?
Your answer should be compact. 0.35. What is the ratio of the Payments (BoP, current US$) in 2005 in Lower middle income to that in OECD members?
Ensure brevity in your answer.  0.06. What is the ratio of the Payments (BoP, current US$) in 2006 in Lower middle income to that in OECD members?
Offer a terse response. 0.07. What is the ratio of the Payments (BoP, current US$) in 2007 in Lower middle income to that in OECD members?
Give a very brief answer. 0.07. What is the ratio of the Payments (BoP, current US$) of 2008 in Lower middle income to that in OECD members?
Provide a short and direct response. 0.08. What is the ratio of the Payments (BoP, current US$) in 2005 in Lower middle income to that in South Asia?
Ensure brevity in your answer.  2.76. What is the ratio of the Payments (BoP, current US$) in 2006 in Lower middle income to that in South Asia?
Keep it short and to the point. 2.67. What is the ratio of the Payments (BoP, current US$) in 2007 in Lower middle income to that in South Asia?
Provide a succinct answer. 2.71. What is the ratio of the Payments (BoP, current US$) of 2008 in Lower middle income to that in South Asia?
Your answer should be compact. 2.65. What is the ratio of the Payments (BoP, current US$) in 2005 in North America to that in OECD members?
Your answer should be very brief. 0.26. What is the ratio of the Payments (BoP, current US$) of 2006 in North America to that in OECD members?
Make the answer very short. 0.26. What is the ratio of the Payments (BoP, current US$) of 2007 in North America to that in OECD members?
Your answer should be compact. 0.24. What is the ratio of the Payments (BoP, current US$) in 2008 in North America to that in OECD members?
Ensure brevity in your answer.  0.23. What is the ratio of the Payments (BoP, current US$) in 2005 in North America to that in South Asia?
Your response must be concise. 11.23. What is the ratio of the Payments (BoP, current US$) of 2006 in North America to that in South Asia?
Provide a short and direct response. 10.61. What is the ratio of the Payments (BoP, current US$) of 2007 in North America to that in South Asia?
Offer a terse response. 9.46. What is the ratio of the Payments (BoP, current US$) of 2008 in North America to that in South Asia?
Offer a terse response. 7.49. What is the ratio of the Payments (BoP, current US$) in 2005 in OECD members to that in South Asia?
Provide a succinct answer. 42.99. What is the ratio of the Payments (BoP, current US$) of 2006 in OECD members to that in South Asia?
Make the answer very short. 40.95. What is the ratio of the Payments (BoP, current US$) in 2007 in OECD members to that in South Asia?
Your answer should be very brief. 39.44. What is the ratio of the Payments (BoP, current US$) in 2008 in OECD members to that in South Asia?
Give a very brief answer. 32.59. What is the difference between the highest and the second highest Payments (BoP, current US$) of 2005?
Your answer should be compact. 8.27e+12. What is the difference between the highest and the second highest Payments (BoP, current US$) of 2006?
Offer a terse response. 9.65e+12. What is the difference between the highest and the second highest Payments (BoP, current US$) in 2007?
Keep it short and to the point. 1.16e+13. What is the difference between the highest and the second highest Payments (BoP, current US$) in 2008?
Offer a terse response. 1.28e+13. What is the difference between the highest and the lowest Payments (BoP, current US$) of 2005?
Ensure brevity in your answer.  1.09e+13. What is the difference between the highest and the lowest Payments (BoP, current US$) in 2006?
Your answer should be very brief. 1.27e+13. What is the difference between the highest and the lowest Payments (BoP, current US$) in 2007?
Provide a succinct answer. 1.49e+13. What is the difference between the highest and the lowest Payments (BoP, current US$) in 2008?
Your answer should be compact. 1.61e+13. 